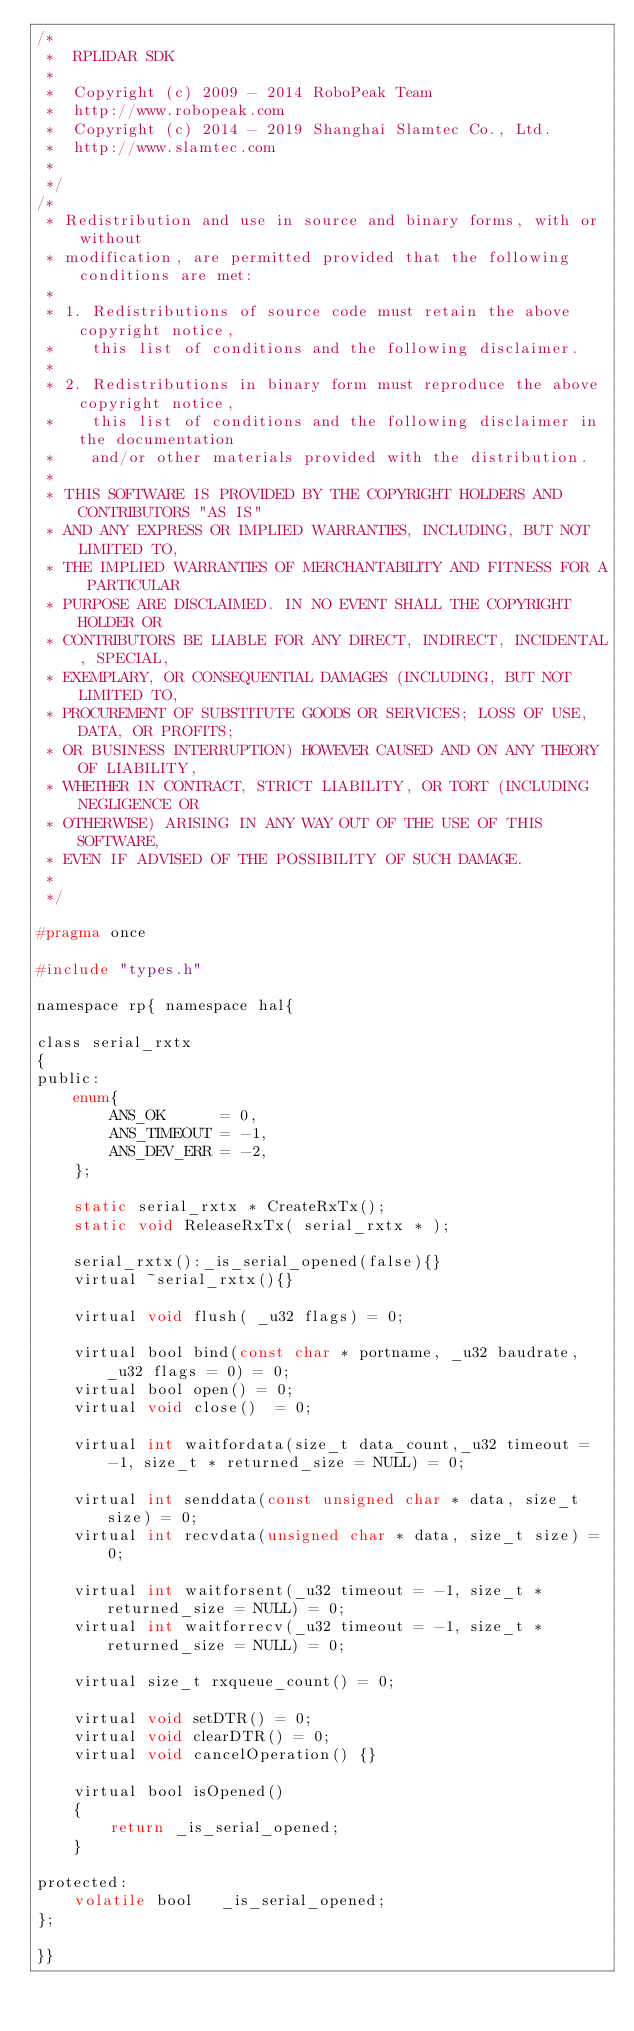Convert code to text. <code><loc_0><loc_0><loc_500><loc_500><_C_>/*
 *  RPLIDAR SDK
 *
 *  Copyright (c) 2009 - 2014 RoboPeak Team
 *  http://www.robopeak.com
 *  Copyright (c) 2014 - 2019 Shanghai Slamtec Co., Ltd.
 *  http://www.slamtec.com
 *
 */
/*
 * Redistribution and use in source and binary forms, with or without 
 * modification, are permitted provided that the following conditions are met:
 *
 * 1. Redistributions of source code must retain the above copyright notice, 
 *    this list of conditions and the following disclaimer.
 *
 * 2. Redistributions in binary form must reproduce the above copyright notice, 
 *    this list of conditions and the following disclaimer in the documentation 
 *    and/or other materials provided with the distribution.
 *
 * THIS SOFTWARE IS PROVIDED BY THE COPYRIGHT HOLDERS AND CONTRIBUTORS "AS IS" 
 * AND ANY EXPRESS OR IMPLIED WARRANTIES, INCLUDING, BUT NOT LIMITED TO, 
 * THE IMPLIED WARRANTIES OF MERCHANTABILITY AND FITNESS FOR A PARTICULAR 
 * PURPOSE ARE DISCLAIMED. IN NO EVENT SHALL THE COPYRIGHT HOLDER OR 
 * CONTRIBUTORS BE LIABLE FOR ANY DIRECT, INDIRECT, INCIDENTAL, SPECIAL, 
 * EXEMPLARY, OR CONSEQUENTIAL DAMAGES (INCLUDING, BUT NOT LIMITED TO, 
 * PROCUREMENT OF SUBSTITUTE GOODS OR SERVICES; LOSS OF USE, DATA, OR PROFITS; 
 * OR BUSINESS INTERRUPTION) HOWEVER CAUSED AND ON ANY THEORY OF LIABILITY, 
 * WHETHER IN CONTRACT, STRICT LIABILITY, OR TORT (INCLUDING NEGLIGENCE OR 
 * OTHERWISE) ARISING IN ANY WAY OUT OF THE USE OF THIS SOFTWARE, 
 * EVEN IF ADVISED OF THE POSSIBILITY OF SUCH DAMAGE.
 *
 */

#pragma once 

#include "types.h"

namespace rp{ namespace hal{

class serial_rxtx
{
public:
    enum{
        ANS_OK      = 0,
        ANS_TIMEOUT = -1,
        ANS_DEV_ERR = -2,
    };

    static serial_rxtx * CreateRxTx();
    static void ReleaseRxTx( serial_rxtx * );

    serial_rxtx():_is_serial_opened(false){}
    virtual ~serial_rxtx(){}

    virtual void flush( _u32 flags) = 0;

    virtual bool bind(const char * portname, _u32 baudrate, _u32 flags = 0) = 0;
    virtual bool open() = 0;
    virtual void close()  = 0;
    
    virtual int waitfordata(size_t data_count,_u32 timeout = -1, size_t * returned_size = NULL) = 0;

    virtual int senddata(const unsigned char * data, size_t size) = 0;
    virtual int recvdata(unsigned char * data, size_t size) = 0;

    virtual int waitforsent(_u32 timeout = -1, size_t * returned_size = NULL) = 0;
    virtual int waitforrecv(_u32 timeout = -1, size_t * returned_size = NULL) = 0;

    virtual size_t rxqueue_count() = 0;

    virtual void setDTR() = 0;
    virtual void clearDTR() = 0;
    virtual void cancelOperation() {}

    virtual bool isOpened()
    {
        return _is_serial_opened;
    }

protected:
    volatile bool   _is_serial_opened;
};

}}



</code> 